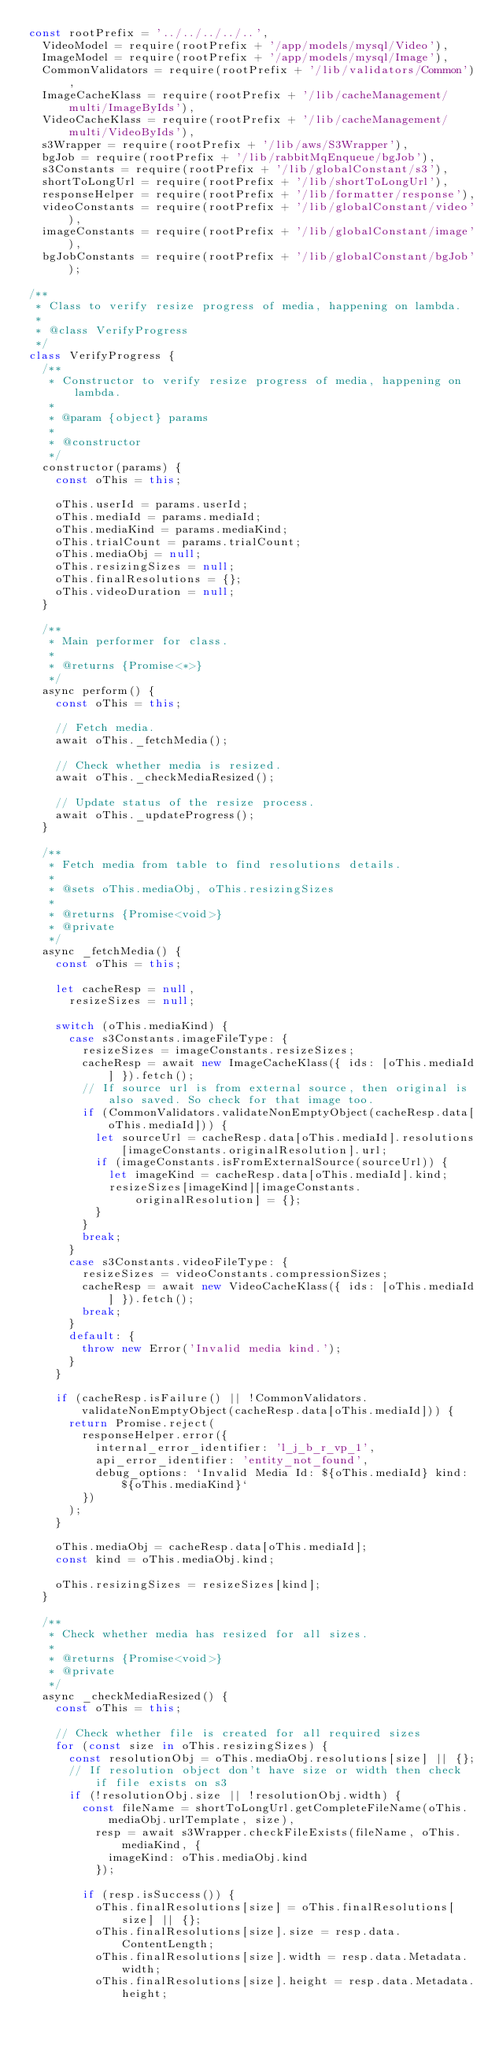<code> <loc_0><loc_0><loc_500><loc_500><_JavaScript_>const rootPrefix = '../../../../..',
  VideoModel = require(rootPrefix + '/app/models/mysql/Video'),
  ImageModel = require(rootPrefix + '/app/models/mysql/Image'),
  CommonValidators = require(rootPrefix + '/lib/validators/Common'),
  ImageCacheKlass = require(rootPrefix + '/lib/cacheManagement/multi/ImageByIds'),
  VideoCacheKlass = require(rootPrefix + '/lib/cacheManagement/multi/VideoByIds'),
  s3Wrapper = require(rootPrefix + '/lib/aws/S3Wrapper'),
  bgJob = require(rootPrefix + '/lib/rabbitMqEnqueue/bgJob'),
  s3Constants = require(rootPrefix + '/lib/globalConstant/s3'),
  shortToLongUrl = require(rootPrefix + '/lib/shortToLongUrl'),
  responseHelper = require(rootPrefix + '/lib/formatter/response'),
  videoConstants = require(rootPrefix + '/lib/globalConstant/video'),
  imageConstants = require(rootPrefix + '/lib/globalConstant/image'),
  bgJobConstants = require(rootPrefix + '/lib/globalConstant/bgJob');

/**
 * Class to verify resize progress of media, happening on lambda.
 *
 * @class VerifyProgress
 */
class VerifyProgress {
  /**
   * Constructor to verify resize progress of media, happening on lambda.
   *
   * @param {object} params
   *
   * @constructor
   */
  constructor(params) {
    const oThis = this;

    oThis.userId = params.userId;
    oThis.mediaId = params.mediaId;
    oThis.mediaKind = params.mediaKind;
    oThis.trialCount = params.trialCount;
    oThis.mediaObj = null;
    oThis.resizingSizes = null;
    oThis.finalResolutions = {};
    oThis.videoDuration = null;
  }

  /**
   * Main performer for class.
   *
   * @returns {Promise<*>}
   */
  async perform() {
    const oThis = this;

    // Fetch media.
    await oThis._fetchMedia();

    // Check whether media is resized.
    await oThis._checkMediaResized();

    // Update status of the resize process.
    await oThis._updateProgress();
  }

  /**
   * Fetch media from table to find resolutions details.
   *
   * @sets oThis.mediaObj, oThis.resizingSizes
   *
   * @returns {Promise<void>}
   * @private
   */
  async _fetchMedia() {
    const oThis = this;

    let cacheResp = null,
      resizeSizes = null;

    switch (oThis.mediaKind) {
      case s3Constants.imageFileType: {
        resizeSizes = imageConstants.resizeSizes;
        cacheResp = await new ImageCacheKlass({ ids: [oThis.mediaId] }).fetch();
        // If source url is from external source, then original is also saved. So check for that image too.
        if (CommonValidators.validateNonEmptyObject(cacheResp.data[oThis.mediaId])) {
          let sourceUrl = cacheResp.data[oThis.mediaId].resolutions[imageConstants.originalResolution].url;
          if (imageConstants.isFromExternalSource(sourceUrl)) {
            let imageKind = cacheResp.data[oThis.mediaId].kind;
            resizeSizes[imageKind][imageConstants.originalResolution] = {};
          }
        }
        break;
      }
      case s3Constants.videoFileType: {
        resizeSizes = videoConstants.compressionSizes;
        cacheResp = await new VideoCacheKlass({ ids: [oThis.mediaId] }).fetch();
        break;
      }
      default: {
        throw new Error('Invalid media kind.');
      }
    }

    if (cacheResp.isFailure() || !CommonValidators.validateNonEmptyObject(cacheResp.data[oThis.mediaId])) {
      return Promise.reject(
        responseHelper.error({
          internal_error_identifier: 'l_j_b_r_vp_1',
          api_error_identifier: 'entity_not_found',
          debug_options: `Invalid Media Id: ${oThis.mediaId} kind: ${oThis.mediaKind}`
        })
      );
    }

    oThis.mediaObj = cacheResp.data[oThis.mediaId];
    const kind = oThis.mediaObj.kind;

    oThis.resizingSizes = resizeSizes[kind];
  }

  /**
   * Check whether media has resized for all sizes.
   *
   * @returns {Promise<void>}
   * @private
   */
  async _checkMediaResized() {
    const oThis = this;

    // Check whether file is created for all required sizes
    for (const size in oThis.resizingSizes) {
      const resolutionObj = oThis.mediaObj.resolutions[size] || {};
      // If resolution object don't have size or width then check if file exists on s3
      if (!resolutionObj.size || !resolutionObj.width) {
        const fileName = shortToLongUrl.getCompleteFileName(oThis.mediaObj.urlTemplate, size),
          resp = await s3Wrapper.checkFileExists(fileName, oThis.mediaKind, {
            imageKind: oThis.mediaObj.kind
          });

        if (resp.isSuccess()) {
          oThis.finalResolutions[size] = oThis.finalResolutions[size] || {};
          oThis.finalResolutions[size].size = resp.data.ContentLength;
          oThis.finalResolutions[size].width = resp.data.Metadata.width;
          oThis.finalResolutions[size].height = resp.data.Metadata.height;</code> 